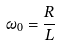<formula> <loc_0><loc_0><loc_500><loc_500>\omega _ { 0 } = \frac { R } { L }</formula> 